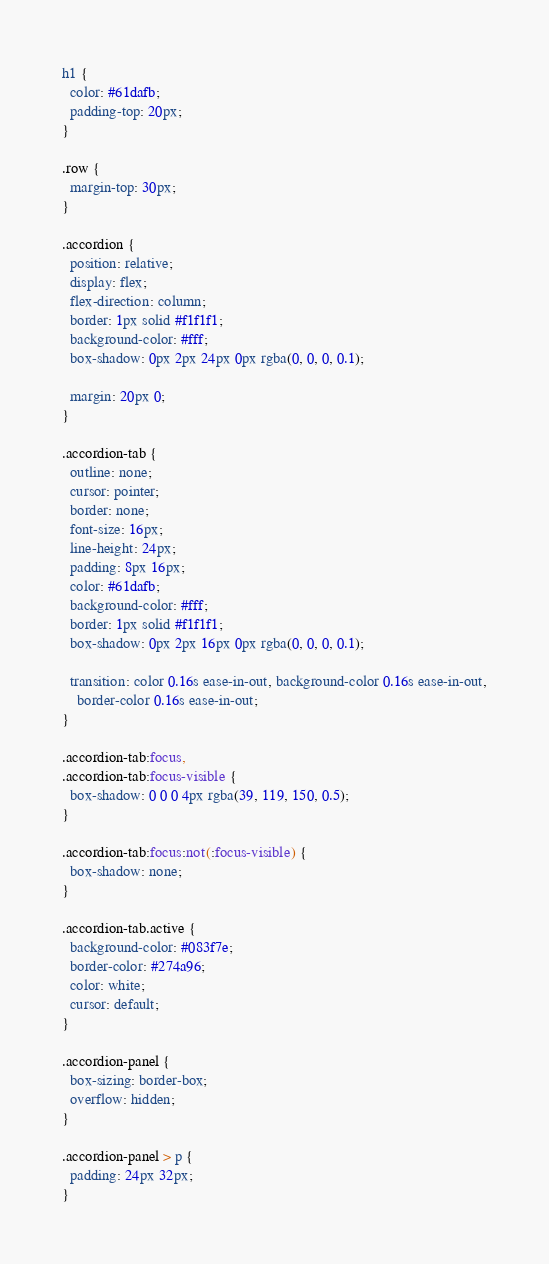<code> <loc_0><loc_0><loc_500><loc_500><_CSS_>h1 {
  color: #61dafb;
  padding-top: 20px;
}

.row {
  margin-top: 30px;
}

.accordion {
  position: relative;
  display: flex;
  flex-direction: column;
  border: 1px solid #f1f1f1;
  background-color: #fff;
  box-shadow: 0px 2px 24px 0px rgba(0, 0, 0, 0.1);

  margin: 20px 0;
}

.accordion-tab {
  outline: none;
  cursor: pointer;
  border: none;
  font-size: 16px;
  line-height: 24px;
  padding: 8px 16px;
  color: #61dafb;
  background-color: #fff;
  border: 1px solid #f1f1f1;
  box-shadow: 0px 2px 16px 0px rgba(0, 0, 0, 0.1);

  transition: color 0.16s ease-in-out, background-color 0.16s ease-in-out,
    border-color 0.16s ease-in-out;
}

.accordion-tab:focus,
.accordion-tab:focus-visible {
  box-shadow: 0 0 0 4px rgba(39, 119, 150, 0.5);
}

.accordion-tab:focus:not(:focus-visible) {
  box-shadow: none;
}

.accordion-tab.active {
  background-color: #083f7e;
  border-color: #274a96;
  color: white;
  cursor: default;
}

.accordion-panel {
  box-sizing: border-box;
  overflow: hidden;
}

.accordion-panel > p {
  padding: 24px 32px;
}</code> 